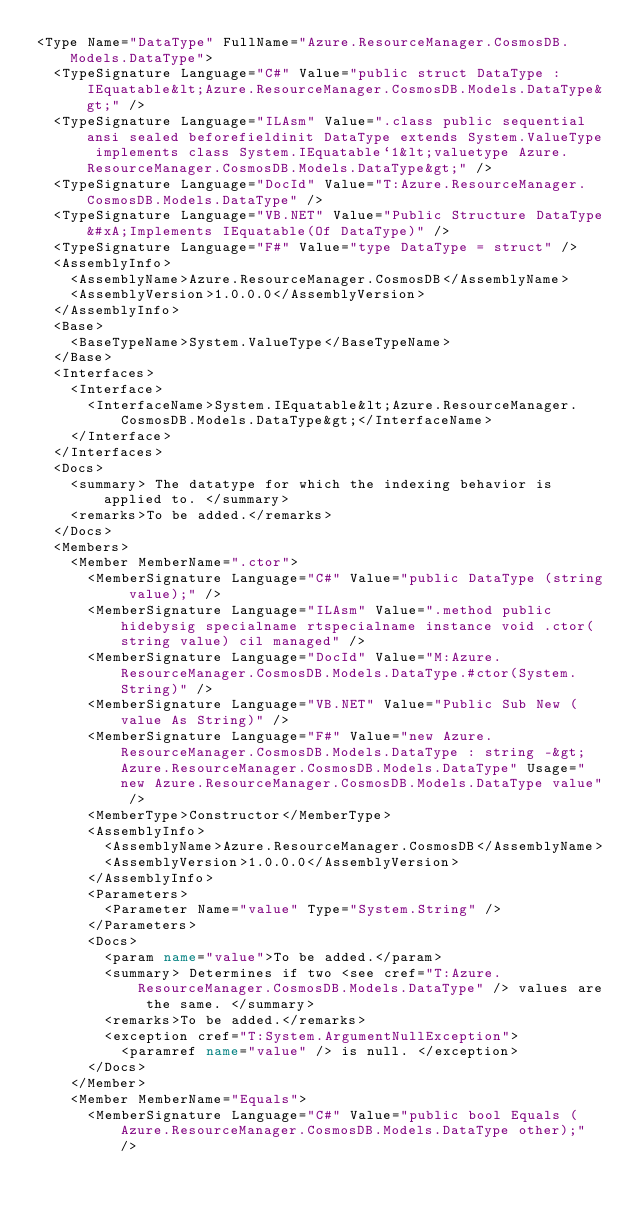<code> <loc_0><loc_0><loc_500><loc_500><_XML_><Type Name="DataType" FullName="Azure.ResourceManager.CosmosDB.Models.DataType">
  <TypeSignature Language="C#" Value="public struct DataType : IEquatable&lt;Azure.ResourceManager.CosmosDB.Models.DataType&gt;" />
  <TypeSignature Language="ILAsm" Value=".class public sequential ansi sealed beforefieldinit DataType extends System.ValueType implements class System.IEquatable`1&lt;valuetype Azure.ResourceManager.CosmosDB.Models.DataType&gt;" />
  <TypeSignature Language="DocId" Value="T:Azure.ResourceManager.CosmosDB.Models.DataType" />
  <TypeSignature Language="VB.NET" Value="Public Structure DataType&#xA;Implements IEquatable(Of DataType)" />
  <TypeSignature Language="F#" Value="type DataType = struct" />
  <AssemblyInfo>
    <AssemblyName>Azure.ResourceManager.CosmosDB</AssemblyName>
    <AssemblyVersion>1.0.0.0</AssemblyVersion>
  </AssemblyInfo>
  <Base>
    <BaseTypeName>System.ValueType</BaseTypeName>
  </Base>
  <Interfaces>
    <Interface>
      <InterfaceName>System.IEquatable&lt;Azure.ResourceManager.CosmosDB.Models.DataType&gt;</InterfaceName>
    </Interface>
  </Interfaces>
  <Docs>
    <summary> The datatype for which the indexing behavior is applied to. </summary>
    <remarks>To be added.</remarks>
  </Docs>
  <Members>
    <Member MemberName=".ctor">
      <MemberSignature Language="C#" Value="public DataType (string value);" />
      <MemberSignature Language="ILAsm" Value=".method public hidebysig specialname rtspecialname instance void .ctor(string value) cil managed" />
      <MemberSignature Language="DocId" Value="M:Azure.ResourceManager.CosmosDB.Models.DataType.#ctor(System.String)" />
      <MemberSignature Language="VB.NET" Value="Public Sub New (value As String)" />
      <MemberSignature Language="F#" Value="new Azure.ResourceManager.CosmosDB.Models.DataType : string -&gt; Azure.ResourceManager.CosmosDB.Models.DataType" Usage="new Azure.ResourceManager.CosmosDB.Models.DataType value" />
      <MemberType>Constructor</MemberType>
      <AssemblyInfo>
        <AssemblyName>Azure.ResourceManager.CosmosDB</AssemblyName>
        <AssemblyVersion>1.0.0.0</AssemblyVersion>
      </AssemblyInfo>
      <Parameters>
        <Parameter Name="value" Type="System.String" />
      </Parameters>
      <Docs>
        <param name="value">To be added.</param>
        <summary> Determines if two <see cref="T:Azure.ResourceManager.CosmosDB.Models.DataType" /> values are the same. </summary>
        <remarks>To be added.</remarks>
        <exception cref="T:System.ArgumentNullException">
          <paramref name="value" /> is null. </exception>
      </Docs>
    </Member>
    <Member MemberName="Equals">
      <MemberSignature Language="C#" Value="public bool Equals (Azure.ResourceManager.CosmosDB.Models.DataType other);" /></code> 